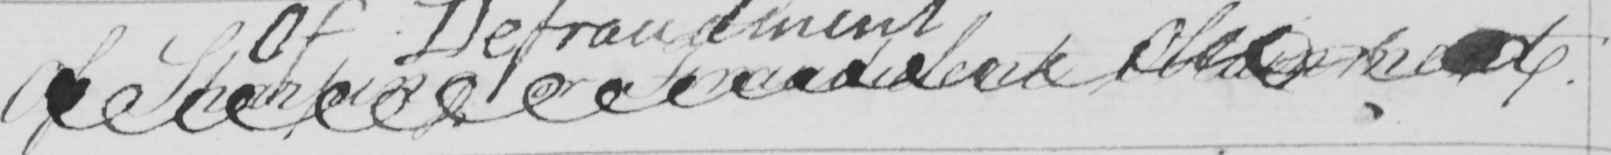Can you tell me what this handwritten text says? Of Sharping on Fraudulent Obtainment . 